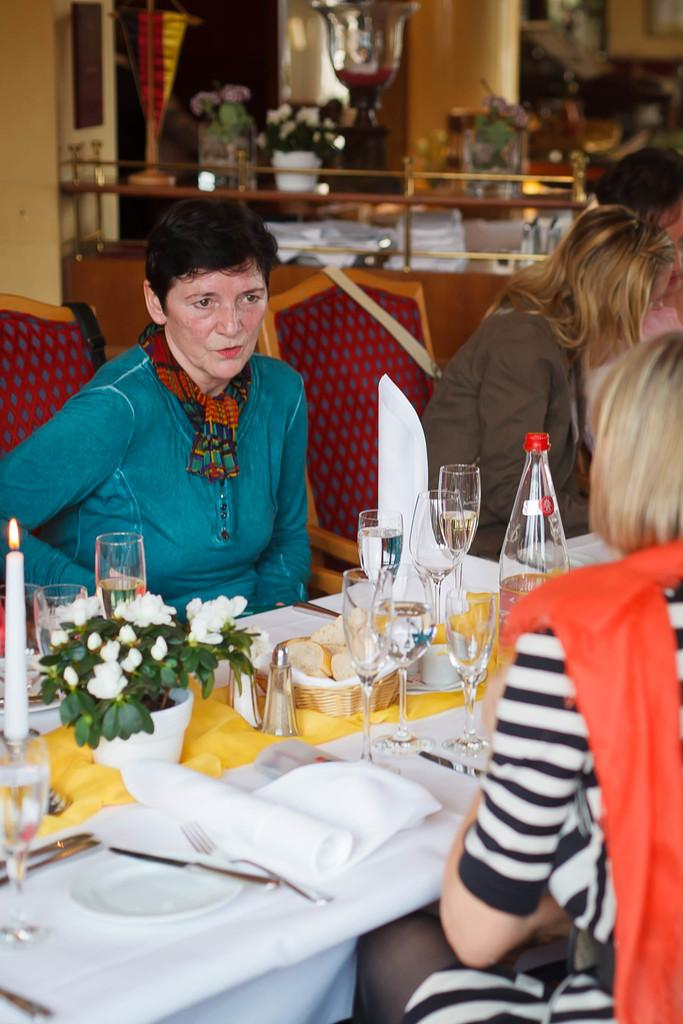How many people are sitting around the dining table in the image? There are three people sitting on chairs around the dining table. What can be seen on the table besides the people? There are wine glasses, a plant pot, a candle, a cloth, plates, and spoons on the table. What type of establishment might this setting be in? The setting appears to be in a hotel. What level of expertise do the ducks have in dining etiquette in the image? There are no ducks present in the image, so it is not possible to determine their level of expertise in dining etiquette. 